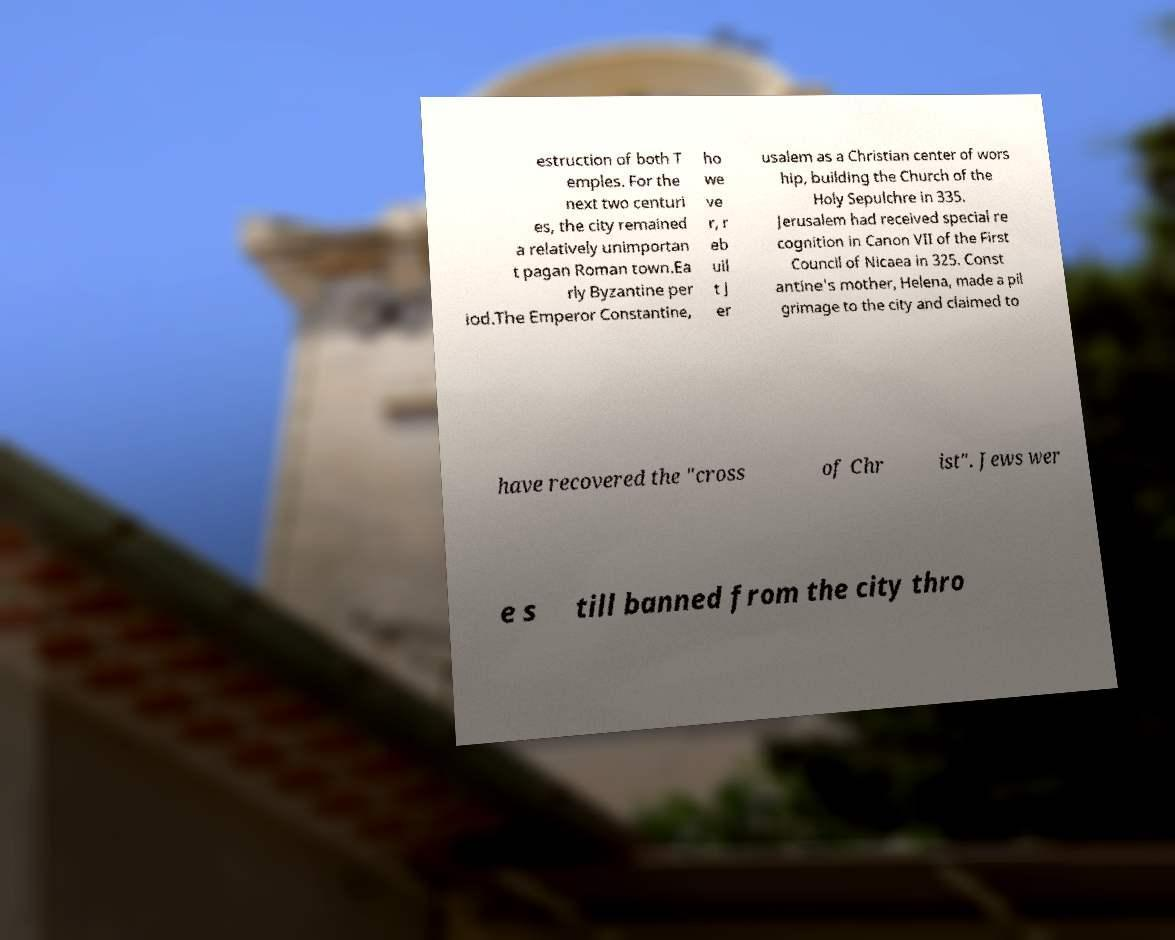For documentation purposes, I need the text within this image transcribed. Could you provide that? estruction of both T emples. For the next two centuri es, the city remained a relatively unimportan t pagan Roman town.Ea rly Byzantine per iod.The Emperor Constantine, ho we ve r, r eb uil t J er usalem as a Christian center of wors hip, building the Church of the Holy Sepulchre in 335. Jerusalem had received special re cognition in Canon VII of the First Council of Nicaea in 325. Const antine's mother, Helena, made a pil grimage to the city and claimed to have recovered the "cross of Chr ist". Jews wer e s till banned from the city thro 